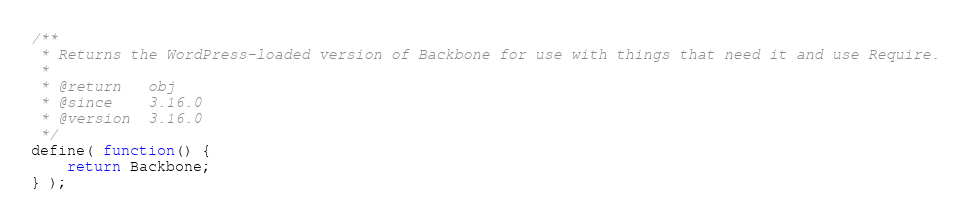Convert code to text. <code><loc_0><loc_0><loc_500><loc_500><_JavaScript_>/**
 * Returns the WordPress-loaded version of Backbone for use with things that need it and use Require.
 *
 * @return   obj
 * @since    3.16.0
 * @version  3.16.0
 */
define( function() {
	return Backbone;
} );
</code> 